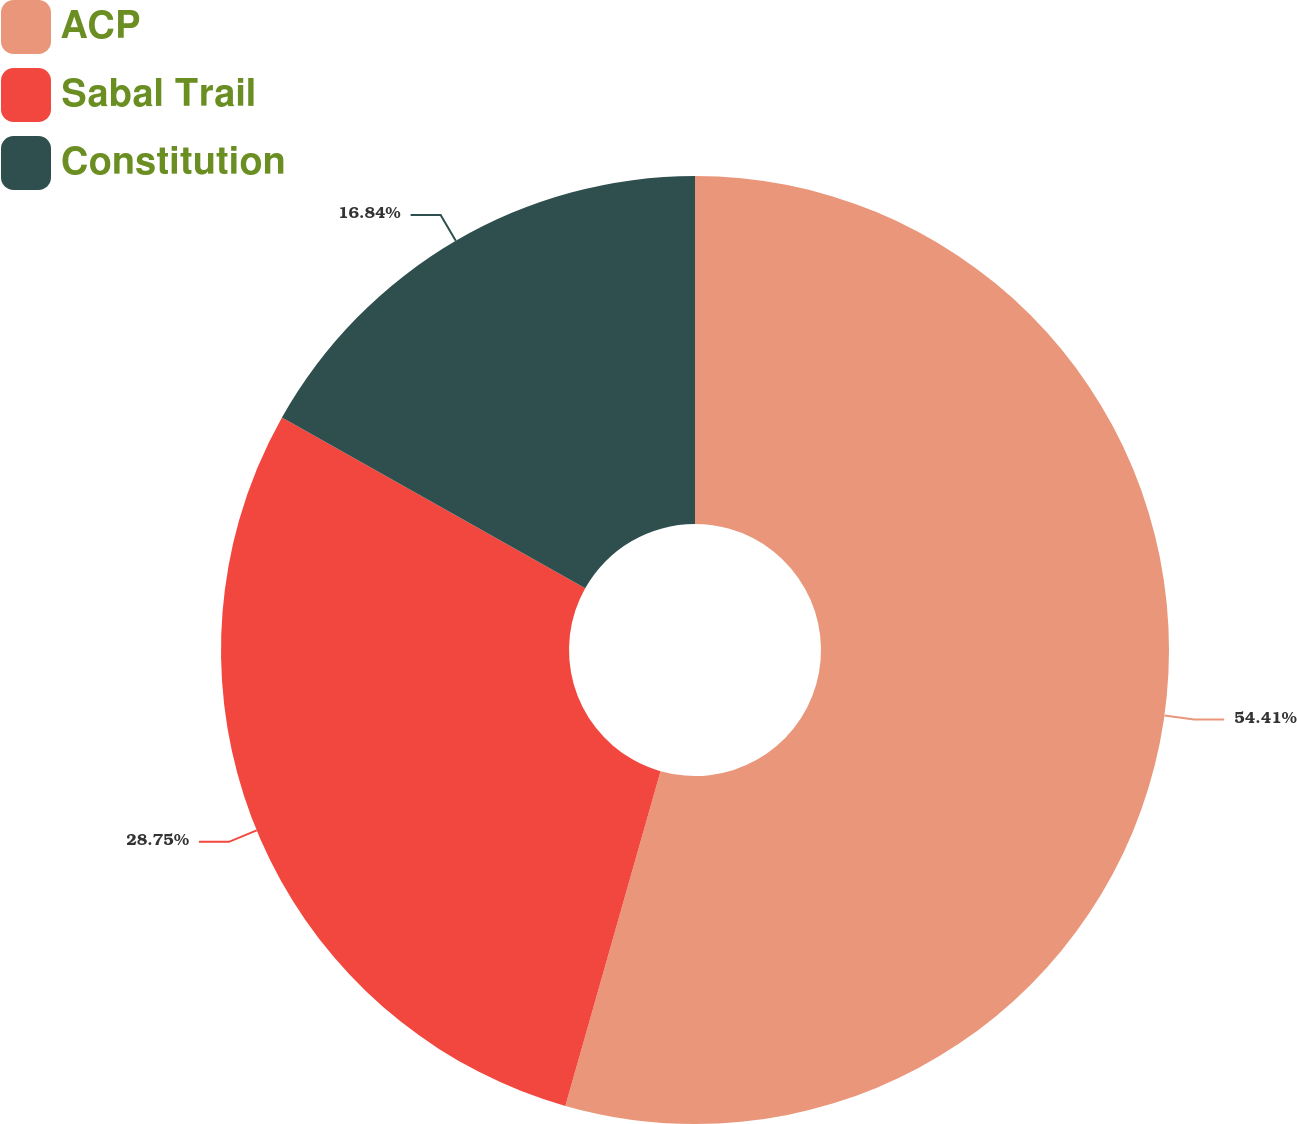Convert chart. <chart><loc_0><loc_0><loc_500><loc_500><pie_chart><fcel>ACP<fcel>Sabal Trail<fcel>Constitution<nl><fcel>54.41%<fcel>28.75%<fcel>16.84%<nl></chart> 